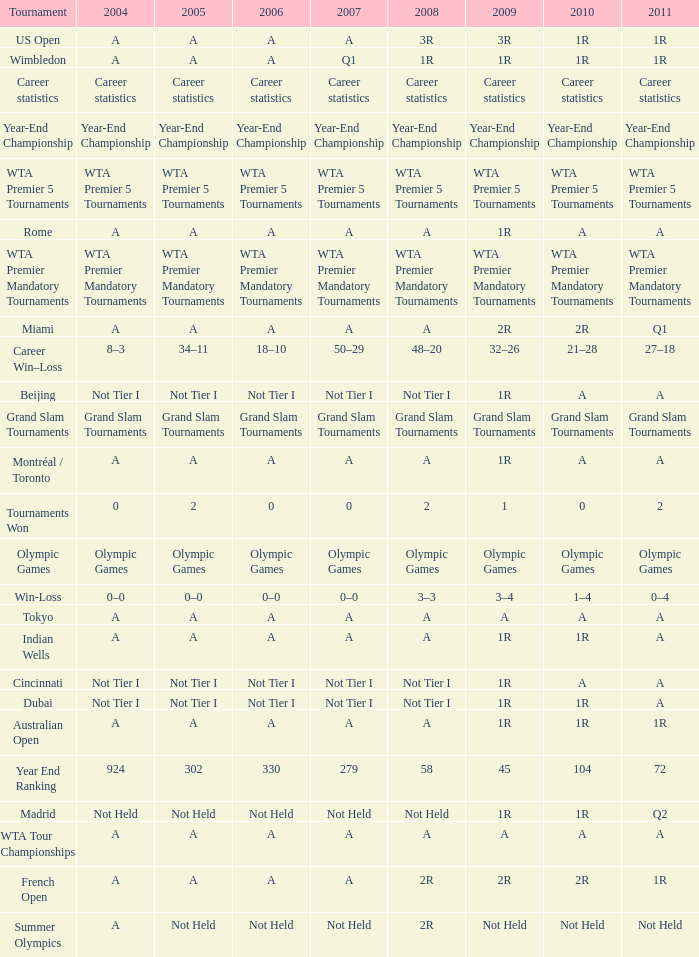What is 2004, when 2008 is "WTA Premier 5 Tournaments"? WTA Premier 5 Tournaments. 